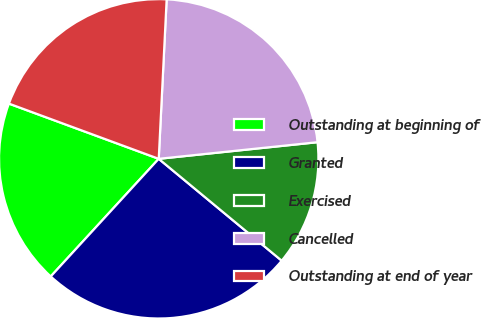<chart> <loc_0><loc_0><loc_500><loc_500><pie_chart><fcel>Outstanding at beginning of<fcel>Granted<fcel>Exercised<fcel>Cancelled<fcel>Outstanding at end of year<nl><fcel>18.8%<fcel>25.81%<fcel>12.67%<fcel>22.55%<fcel>20.17%<nl></chart> 